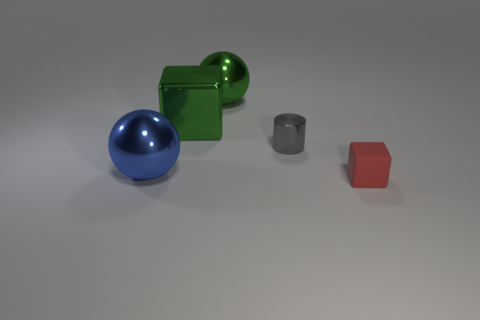Subtract all balls. How many objects are left? 3 Add 2 big shiny blocks. How many objects exist? 7 Add 5 gray shiny cylinders. How many gray shiny cylinders are left? 6 Add 2 small brown matte balls. How many small brown matte balls exist? 2 Subtract 1 red cubes. How many objects are left? 4 Subtract all big metallic spheres. Subtract all metallic spheres. How many objects are left? 1 